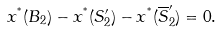Convert formula to latex. <formula><loc_0><loc_0><loc_500><loc_500>x ^ { ^ { * } } ( B _ { 2 } ) - x ^ { ^ { * } } ( S _ { 2 } ^ { \prime } ) - x ^ { ^ { * } } ( \overline { S } _ { 2 } ^ { \prime } ) = 0 .</formula> 